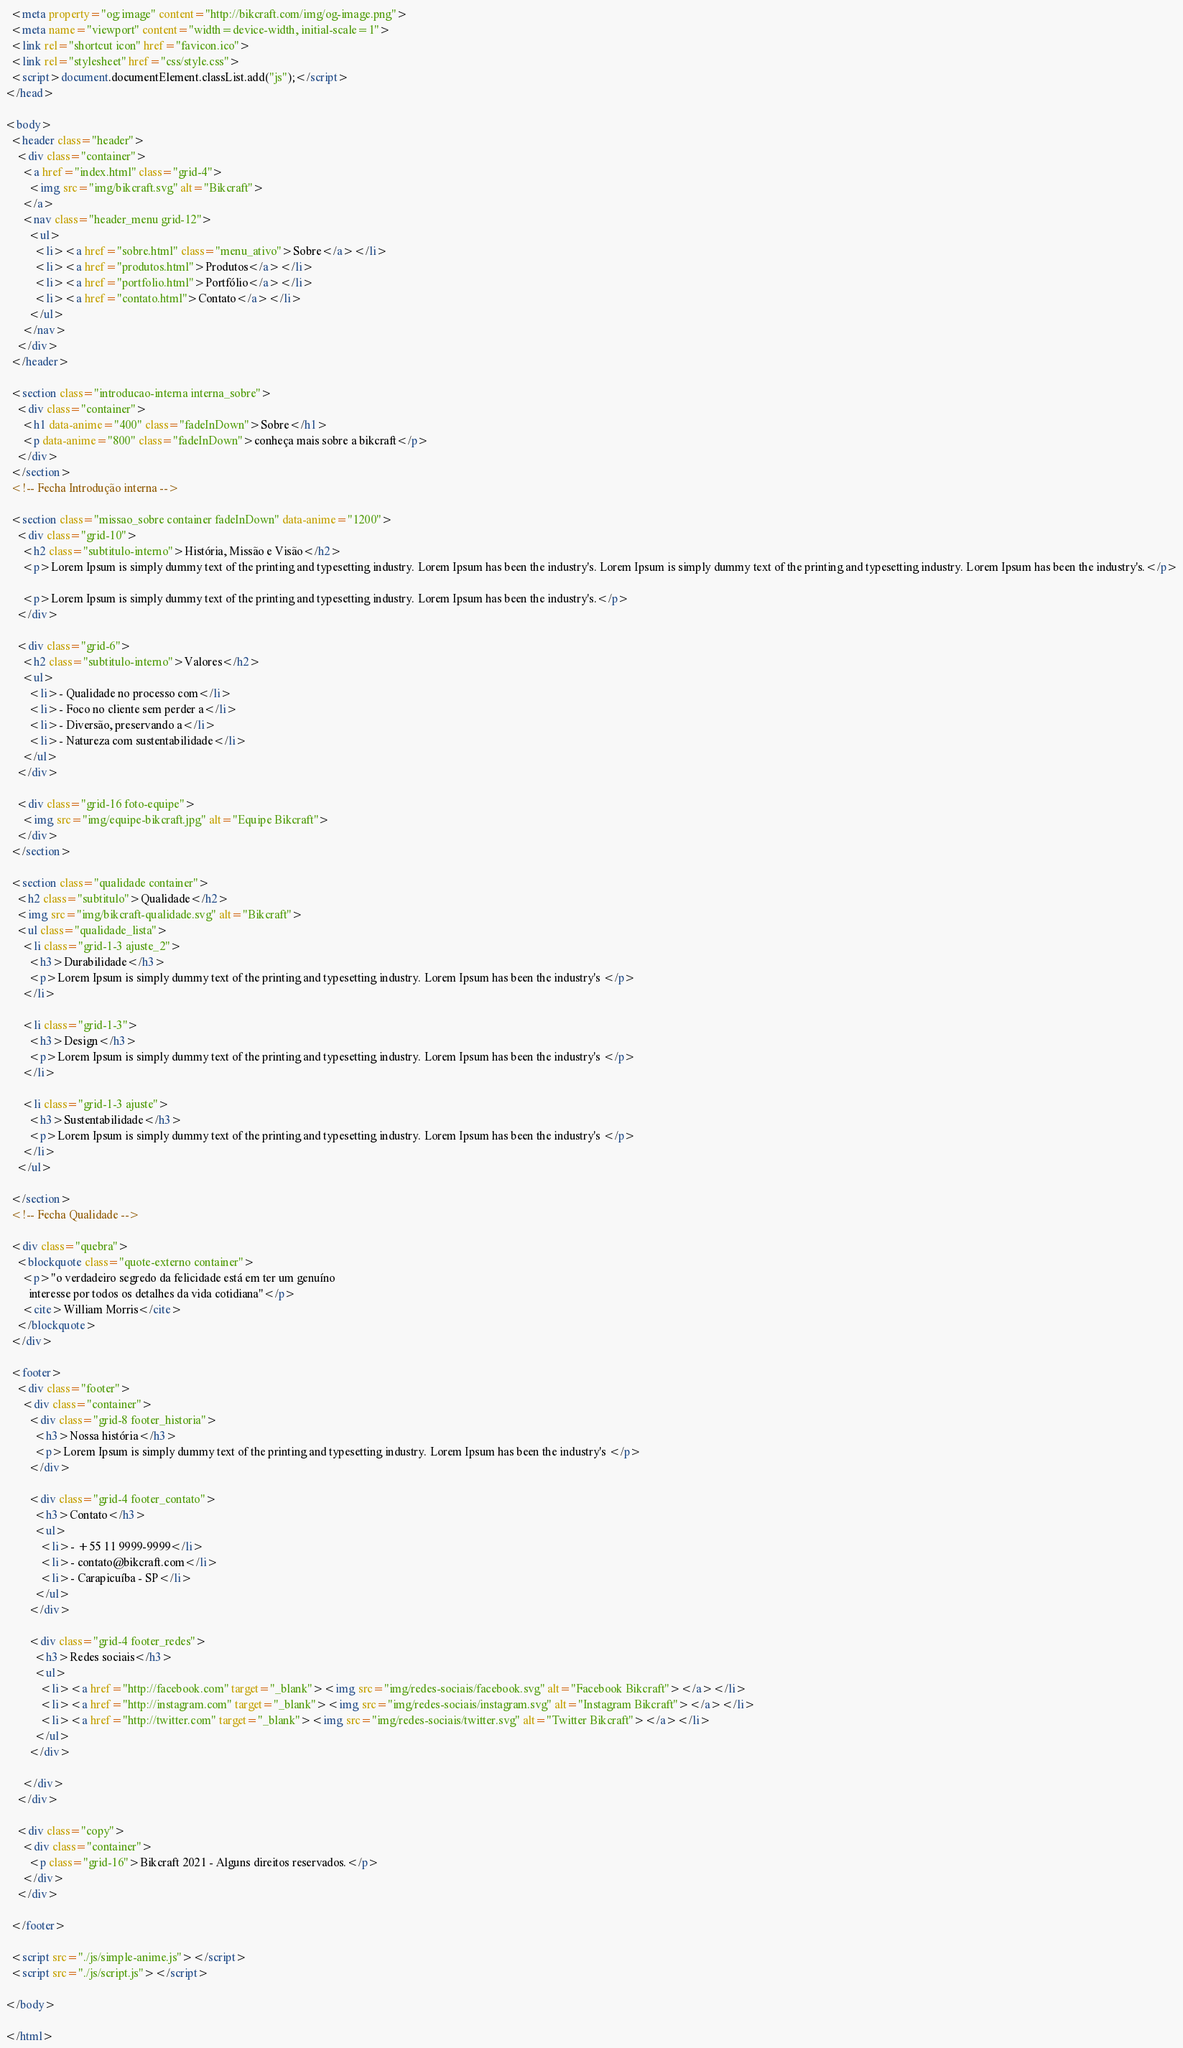<code> <loc_0><loc_0><loc_500><loc_500><_HTML_>  <meta property="og:image" content="http://bikcraft.com/img/og-image.png">
  <meta name="viewport" content="width=device-width, initial-scale=1">
  <link rel="shortcut icon" href="favicon.ico">
  <link rel="stylesheet" href="css/style.css">
  <script>document.documentElement.classList.add("js");</script>
</head>

<body>
  <header class="header">
    <div class="container">
      <a href="index.html" class="grid-4">
        <img src="img/bikcraft.svg" alt="Bikcraft">
      </a>
      <nav class="header_menu grid-12">
        <ul>
          <li><a href="sobre.html" class="menu_ativo">Sobre</a></li>
          <li><a href="produtos.html">Produtos</a></li>
          <li><a href="portfolio.html">Portfólio</a></li>
          <li><a href="contato.html">Contato</a></li>
        </ul>
      </nav>
    </div>
  </header>

  <section class="introducao-interna interna_sobre">
    <div class="container">
      <h1 data-anime="400" class="fadeInDown">Sobre</h1>
      <p data-anime="800" class="fadeInDown">conheça mais sobre a bikcraft</p>
    </div>
  </section>
  <!-- Fecha Introdução interna -->

  <section class="missao_sobre container fadeInDown" data-anime="1200">
    <div class="grid-10">
      <h2 class="subtitulo-interno">História, Missão e Visão</h2>
      <p>Lorem Ipsum is simply dummy text of the printing and typesetting industry. Lorem Ipsum has been the industry's. Lorem Ipsum is simply dummy text of the printing and typesetting industry. Lorem Ipsum has been the industry's.</p>

      <p>Lorem Ipsum is simply dummy text of the printing and typesetting industry. Lorem Ipsum has been the industry's.</p>
    </div>

    <div class="grid-6">
      <h2 class="subtitulo-interno">Valores</h2>
      <ul>
        <li>- Qualidade no processo com</li>
        <li>- Foco no cliente sem perder a</li>
        <li>- Diversão, preservando a</li>
        <li>- Natureza com sustentabilidade</li>
      </ul>
    </div>

    <div class="grid-16 foto-equipe">
      <img src="img/equipe-bikcraft.jpg" alt="Equipe Bikcraft">
    </div>
  </section>

  <section class="qualidade container">
    <h2 class="subtitulo">Qualidade</h2>
    <img src="img/bikcraft-qualidade.svg" alt="Bikcraft">
    <ul class="qualidade_lista">
      <li class="grid-1-3 ajuste_2">
        <h3>Durabilidade</h3>
        <p>Lorem Ipsum is simply dummy text of the printing and typesetting industry. Lorem Ipsum has been the industry's </p>
      </li>

      <li class="grid-1-3">
        <h3>Design</h3>
        <p>Lorem Ipsum is simply dummy text of the printing and typesetting industry. Lorem Ipsum has been the industry's </p>
      </li>

      <li class="grid-1-3 ajuste">
        <h3>Sustentabilidade</h3>
        <p>Lorem Ipsum is simply dummy text of the printing and typesetting industry. Lorem Ipsum has been the industry's </p>
      </li>
    </ul>

  </section>
  <!-- Fecha Qualidade -->

  <div class="quebra">
    <blockquote class="quote-externo container">
      <p>"o verdadeiro segredo da felicidade está em ter um genuíno
        interesse por todos os detalhes da vida cotidiana"</p>
      <cite>William Morris</cite>
    </blockquote>
  </div>

  <footer>
    <div class="footer">
      <div class="container">
        <div class="grid-8 footer_historia">
          <h3>Nossa história</h3>
          <p>Lorem Ipsum is simply dummy text of the printing and typesetting industry. Lorem Ipsum has been the industry's </p>
        </div>

        <div class="grid-4 footer_contato">
          <h3>Contato</h3>
          <ul>
            <li>- +55 11 9999-9999</li>
            <li>- contato@bikcraft.com</li>
            <li>- Carapicuíba - SP</li>
          </ul>
        </div>

        <div class="grid-4 footer_redes">
          <h3>Redes sociais</h3>
          <ul>
            <li><a href="http://facebook.com" target="_blank"><img src="img/redes-sociais/facebook.svg" alt="Facebook Bikcraft"></a></li>
            <li><a href="http://instagram.com" target="_blank"><img src="img/redes-sociais/instagram.svg" alt="Instagram Bikcraft"></a></li>
            <li><a href="http://twitter.com" target="_blank"><img src="img/redes-sociais/twitter.svg" alt="Twitter Bikcraft"></a></li>
          </ul>
        </div>

      </div>
    </div>

    <div class="copy">
      <div class="container">
        <p class="grid-16">Bikcraft 2021 - Alguns direitos reservados.</p>
      </div>
    </div>

  </footer>

  <script src="./js/simple-anime.js"></script>
  <script src="./js/script.js"></script>

</body>

</html></code> 